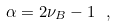<formula> <loc_0><loc_0><loc_500><loc_500>\alpha = 2 \nu _ { B } - 1 \ ,</formula> 